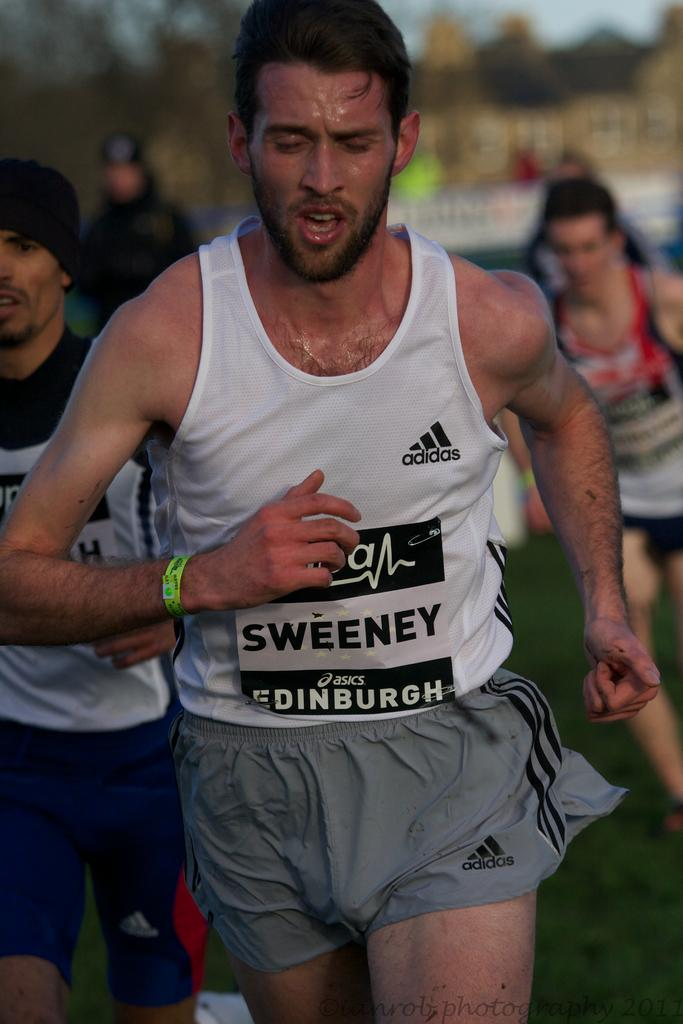<image>
Relay a brief, clear account of the picture shown. Men are running in a race sweating in adidas outfits 